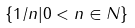<formula> <loc_0><loc_0><loc_500><loc_500>\{ 1 / n | 0 < n \in N \}</formula> 